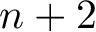Convert formula to latex. <formula><loc_0><loc_0><loc_500><loc_500>n + 2</formula> 